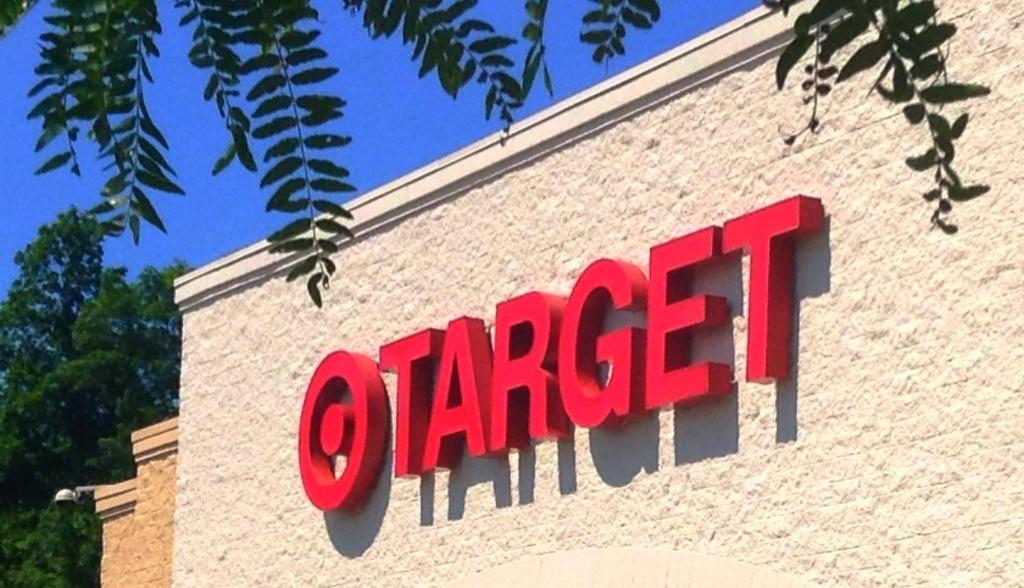What is written on the wall in the image? The facts do not specify the content of the text on the wall. What can be seen in the background of the image? Trees and the sky are visible in the background of the image. What type of plantation can be seen in the image? There is no plantation present in the image. How does the wall have a good grip in the image? The wall's grip is not mentioned or visible in the image. 